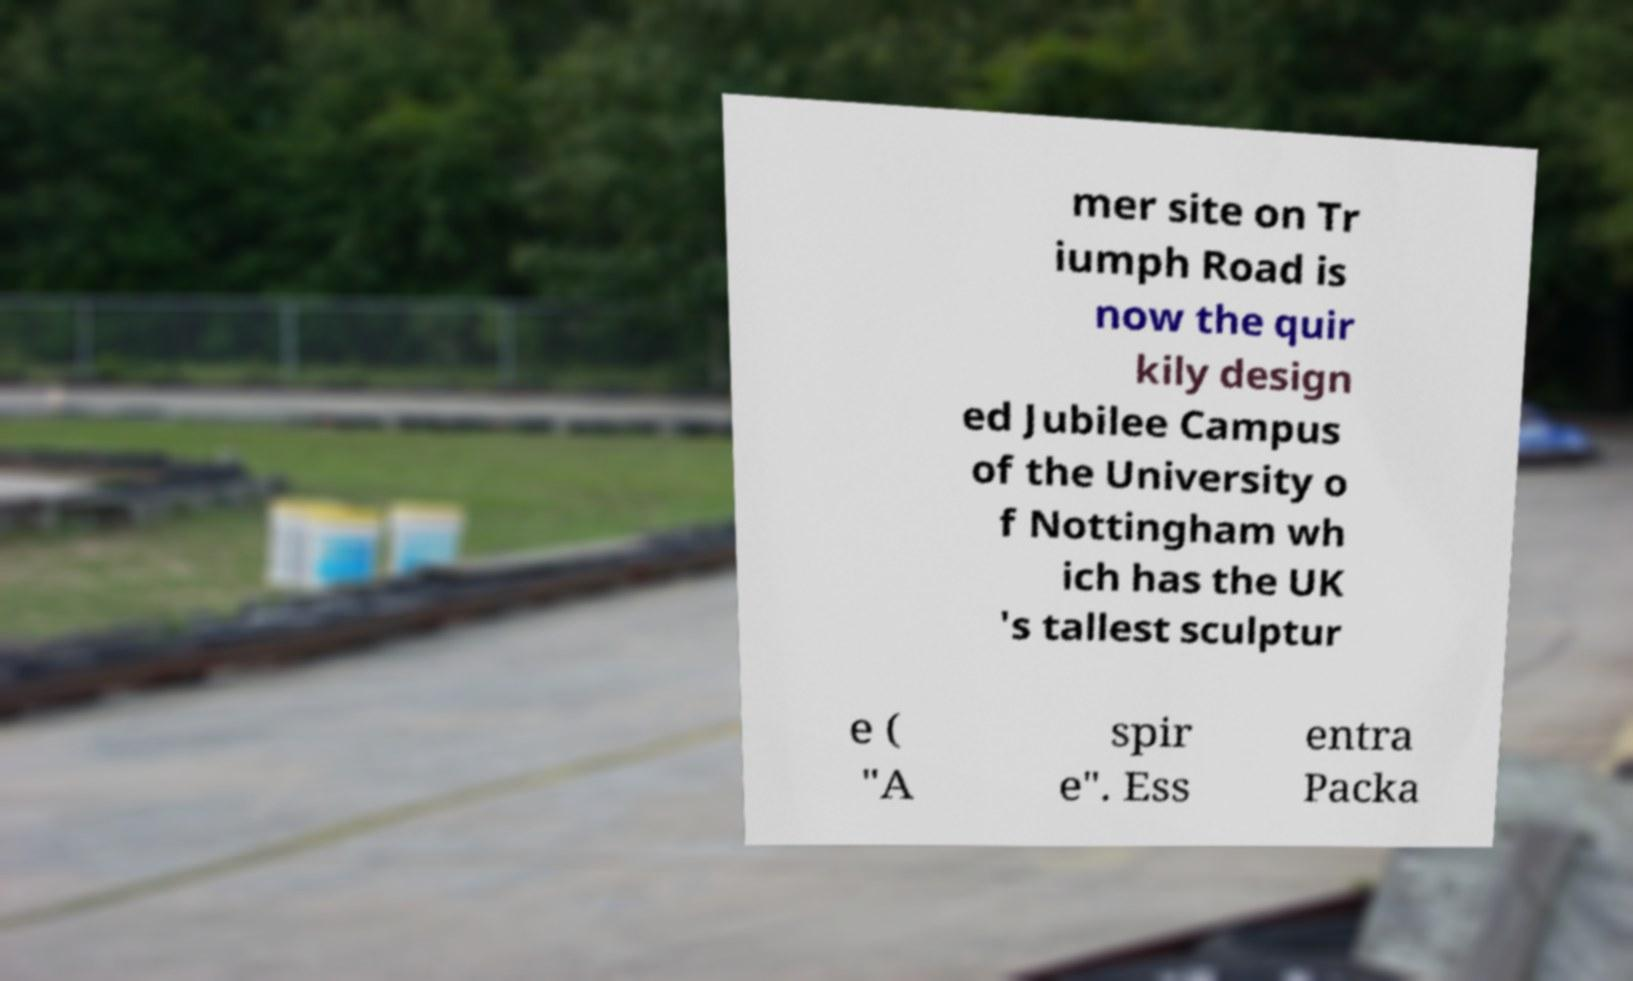Can you read and provide the text displayed in the image?This photo seems to have some interesting text. Can you extract and type it out for me? mer site on Tr iumph Road is now the quir kily design ed Jubilee Campus of the University o f Nottingham wh ich has the UK 's tallest sculptur e ( "A spir e". Ess entra Packa 